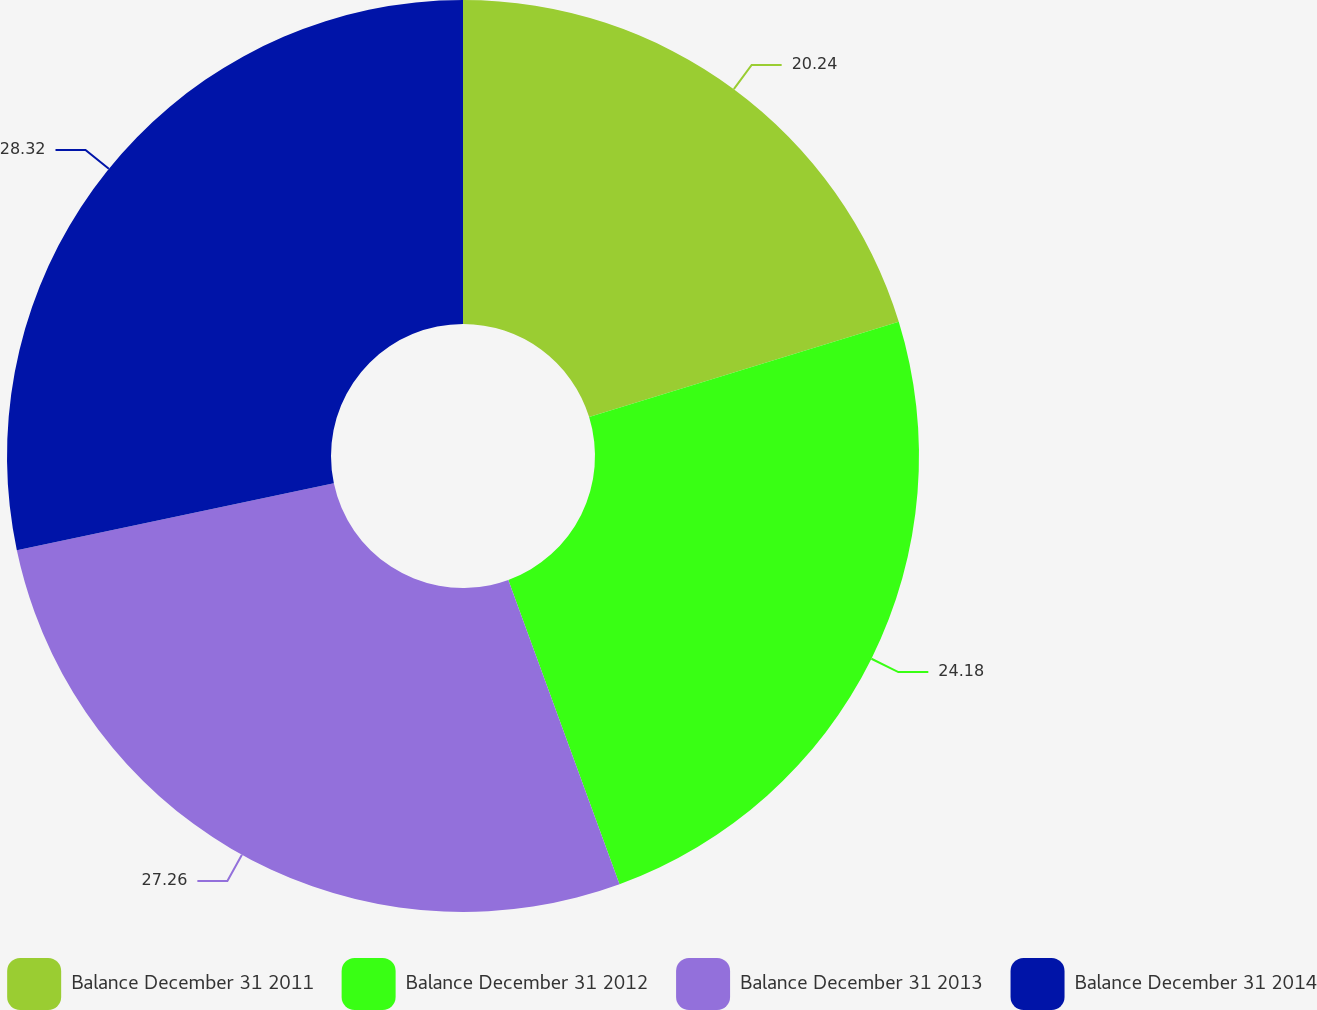Convert chart. <chart><loc_0><loc_0><loc_500><loc_500><pie_chart><fcel>Balance December 31 2011<fcel>Balance December 31 2012<fcel>Balance December 31 2013<fcel>Balance December 31 2014<nl><fcel>20.24%<fcel>24.18%<fcel>27.26%<fcel>28.31%<nl></chart> 